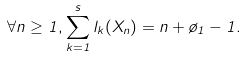<formula> <loc_0><loc_0><loc_500><loc_500>\forall n \geq 1 , \sum _ { k = 1 } ^ { s } l _ { k } ( X _ { n } ) = n + \tau _ { 1 } - 1 .</formula> 